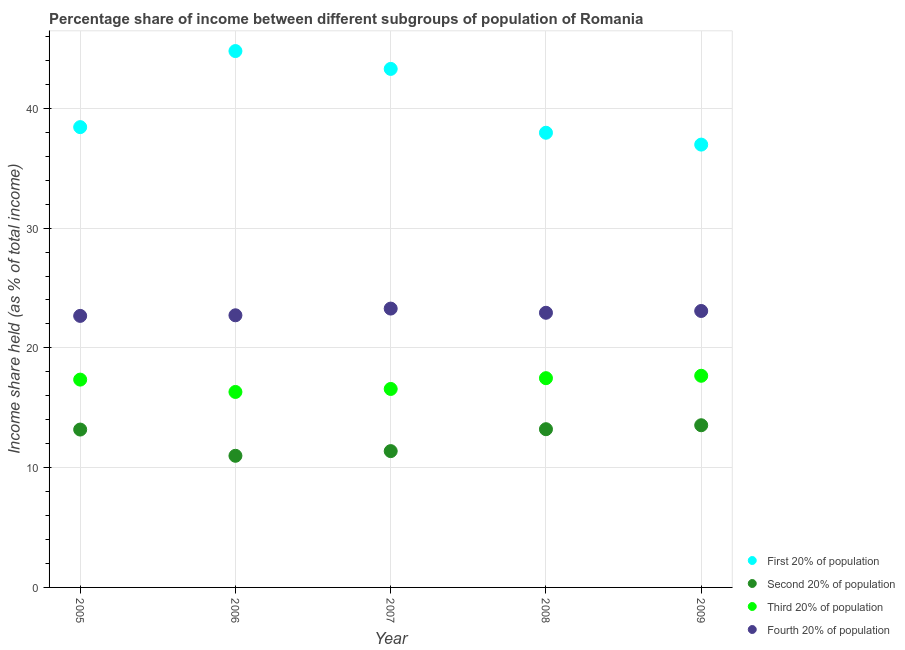What is the share of the income held by third 20% of the population in 2005?
Provide a short and direct response. 17.35. Across all years, what is the maximum share of the income held by fourth 20% of the population?
Your response must be concise. 23.28. Across all years, what is the minimum share of the income held by fourth 20% of the population?
Offer a terse response. 22.67. What is the total share of the income held by first 20% of the population in the graph?
Offer a very short reply. 201.43. What is the difference between the share of the income held by first 20% of the population in 2007 and that in 2008?
Offer a very short reply. 5.33. What is the difference between the share of the income held by first 20% of the population in 2007 and the share of the income held by fourth 20% of the population in 2005?
Your answer should be very brief. 20.62. What is the average share of the income held by third 20% of the population per year?
Provide a succinct answer. 17.08. In the year 2006, what is the difference between the share of the income held by fourth 20% of the population and share of the income held by first 20% of the population?
Make the answer very short. -22.06. In how many years, is the share of the income held by third 20% of the population greater than 20 %?
Give a very brief answer. 0. What is the ratio of the share of the income held by third 20% of the population in 2005 to that in 2006?
Provide a short and direct response. 1.06. Is the difference between the share of the income held by fourth 20% of the population in 2005 and 2009 greater than the difference between the share of the income held by first 20% of the population in 2005 and 2009?
Make the answer very short. No. What is the difference between the highest and the second highest share of the income held by third 20% of the population?
Keep it short and to the point. 0.2. What is the difference between the highest and the lowest share of the income held by first 20% of the population?
Keep it short and to the point. 7.81. Is it the case that in every year, the sum of the share of the income held by fourth 20% of the population and share of the income held by first 20% of the population is greater than the sum of share of the income held by third 20% of the population and share of the income held by second 20% of the population?
Your response must be concise. No. Is it the case that in every year, the sum of the share of the income held by first 20% of the population and share of the income held by second 20% of the population is greater than the share of the income held by third 20% of the population?
Give a very brief answer. Yes. Does the share of the income held by third 20% of the population monotonically increase over the years?
Provide a succinct answer. No. Is the share of the income held by fourth 20% of the population strictly greater than the share of the income held by second 20% of the population over the years?
Your response must be concise. Yes. How many dotlines are there?
Your answer should be compact. 4. What is the difference between two consecutive major ticks on the Y-axis?
Your answer should be compact. 10. Are the values on the major ticks of Y-axis written in scientific E-notation?
Your answer should be compact. No. Where does the legend appear in the graph?
Offer a terse response. Bottom right. How many legend labels are there?
Your response must be concise. 4. What is the title of the graph?
Your response must be concise. Percentage share of income between different subgroups of population of Romania. What is the label or title of the Y-axis?
Your response must be concise. Income share held (as % of total income). What is the Income share held (as % of total income) in First 20% of population in 2005?
Your answer should be very brief. 38.43. What is the Income share held (as % of total income) of Second 20% of population in 2005?
Offer a terse response. 13.18. What is the Income share held (as % of total income) in Third 20% of population in 2005?
Ensure brevity in your answer.  17.35. What is the Income share held (as % of total income) in Fourth 20% of population in 2005?
Keep it short and to the point. 22.67. What is the Income share held (as % of total income) of First 20% of population in 2006?
Give a very brief answer. 44.78. What is the Income share held (as % of total income) in Second 20% of population in 2006?
Your answer should be compact. 10.99. What is the Income share held (as % of total income) in Third 20% of population in 2006?
Ensure brevity in your answer.  16.32. What is the Income share held (as % of total income) in Fourth 20% of population in 2006?
Your response must be concise. 22.72. What is the Income share held (as % of total income) in First 20% of population in 2007?
Your answer should be compact. 43.29. What is the Income share held (as % of total income) in Second 20% of population in 2007?
Make the answer very short. 11.38. What is the Income share held (as % of total income) in Third 20% of population in 2007?
Your answer should be very brief. 16.57. What is the Income share held (as % of total income) in Fourth 20% of population in 2007?
Offer a terse response. 23.28. What is the Income share held (as % of total income) of First 20% of population in 2008?
Provide a short and direct response. 37.96. What is the Income share held (as % of total income) in Second 20% of population in 2008?
Your answer should be very brief. 13.21. What is the Income share held (as % of total income) of Third 20% of population in 2008?
Make the answer very short. 17.47. What is the Income share held (as % of total income) of Fourth 20% of population in 2008?
Provide a succinct answer. 22.93. What is the Income share held (as % of total income) of First 20% of population in 2009?
Keep it short and to the point. 36.97. What is the Income share held (as % of total income) in Second 20% of population in 2009?
Your answer should be compact. 13.54. What is the Income share held (as % of total income) in Third 20% of population in 2009?
Your answer should be compact. 17.67. What is the Income share held (as % of total income) of Fourth 20% of population in 2009?
Provide a short and direct response. 23.08. Across all years, what is the maximum Income share held (as % of total income) of First 20% of population?
Your response must be concise. 44.78. Across all years, what is the maximum Income share held (as % of total income) in Second 20% of population?
Provide a short and direct response. 13.54. Across all years, what is the maximum Income share held (as % of total income) of Third 20% of population?
Your response must be concise. 17.67. Across all years, what is the maximum Income share held (as % of total income) of Fourth 20% of population?
Keep it short and to the point. 23.28. Across all years, what is the minimum Income share held (as % of total income) of First 20% of population?
Make the answer very short. 36.97. Across all years, what is the minimum Income share held (as % of total income) in Second 20% of population?
Your answer should be compact. 10.99. Across all years, what is the minimum Income share held (as % of total income) in Third 20% of population?
Provide a succinct answer. 16.32. Across all years, what is the minimum Income share held (as % of total income) in Fourth 20% of population?
Offer a very short reply. 22.67. What is the total Income share held (as % of total income) in First 20% of population in the graph?
Ensure brevity in your answer.  201.43. What is the total Income share held (as % of total income) in Second 20% of population in the graph?
Your answer should be very brief. 62.3. What is the total Income share held (as % of total income) in Third 20% of population in the graph?
Your answer should be compact. 85.38. What is the total Income share held (as % of total income) in Fourth 20% of population in the graph?
Give a very brief answer. 114.68. What is the difference between the Income share held (as % of total income) of First 20% of population in 2005 and that in 2006?
Your answer should be compact. -6.35. What is the difference between the Income share held (as % of total income) of Second 20% of population in 2005 and that in 2006?
Give a very brief answer. 2.19. What is the difference between the Income share held (as % of total income) in Fourth 20% of population in 2005 and that in 2006?
Your answer should be compact. -0.05. What is the difference between the Income share held (as % of total income) of First 20% of population in 2005 and that in 2007?
Your answer should be compact. -4.86. What is the difference between the Income share held (as % of total income) in Second 20% of population in 2005 and that in 2007?
Provide a succinct answer. 1.8. What is the difference between the Income share held (as % of total income) in Third 20% of population in 2005 and that in 2007?
Your response must be concise. 0.78. What is the difference between the Income share held (as % of total income) in Fourth 20% of population in 2005 and that in 2007?
Keep it short and to the point. -0.61. What is the difference between the Income share held (as % of total income) in First 20% of population in 2005 and that in 2008?
Your answer should be compact. 0.47. What is the difference between the Income share held (as % of total income) in Second 20% of population in 2005 and that in 2008?
Ensure brevity in your answer.  -0.03. What is the difference between the Income share held (as % of total income) of Third 20% of population in 2005 and that in 2008?
Provide a succinct answer. -0.12. What is the difference between the Income share held (as % of total income) of Fourth 20% of population in 2005 and that in 2008?
Provide a succinct answer. -0.26. What is the difference between the Income share held (as % of total income) of First 20% of population in 2005 and that in 2009?
Offer a very short reply. 1.46. What is the difference between the Income share held (as % of total income) of Second 20% of population in 2005 and that in 2009?
Offer a terse response. -0.36. What is the difference between the Income share held (as % of total income) of Third 20% of population in 2005 and that in 2009?
Your answer should be compact. -0.32. What is the difference between the Income share held (as % of total income) of Fourth 20% of population in 2005 and that in 2009?
Keep it short and to the point. -0.41. What is the difference between the Income share held (as % of total income) of First 20% of population in 2006 and that in 2007?
Your answer should be compact. 1.49. What is the difference between the Income share held (as % of total income) in Second 20% of population in 2006 and that in 2007?
Provide a short and direct response. -0.39. What is the difference between the Income share held (as % of total income) of Fourth 20% of population in 2006 and that in 2007?
Your answer should be compact. -0.56. What is the difference between the Income share held (as % of total income) of First 20% of population in 2006 and that in 2008?
Ensure brevity in your answer.  6.82. What is the difference between the Income share held (as % of total income) in Second 20% of population in 2006 and that in 2008?
Your response must be concise. -2.22. What is the difference between the Income share held (as % of total income) of Third 20% of population in 2006 and that in 2008?
Provide a short and direct response. -1.15. What is the difference between the Income share held (as % of total income) in Fourth 20% of population in 2006 and that in 2008?
Offer a terse response. -0.21. What is the difference between the Income share held (as % of total income) in First 20% of population in 2006 and that in 2009?
Your response must be concise. 7.81. What is the difference between the Income share held (as % of total income) of Second 20% of population in 2006 and that in 2009?
Provide a succinct answer. -2.55. What is the difference between the Income share held (as % of total income) of Third 20% of population in 2006 and that in 2009?
Make the answer very short. -1.35. What is the difference between the Income share held (as % of total income) in Fourth 20% of population in 2006 and that in 2009?
Your answer should be very brief. -0.36. What is the difference between the Income share held (as % of total income) of First 20% of population in 2007 and that in 2008?
Ensure brevity in your answer.  5.33. What is the difference between the Income share held (as % of total income) of Second 20% of population in 2007 and that in 2008?
Ensure brevity in your answer.  -1.83. What is the difference between the Income share held (as % of total income) of Third 20% of population in 2007 and that in 2008?
Make the answer very short. -0.9. What is the difference between the Income share held (as % of total income) in First 20% of population in 2007 and that in 2009?
Keep it short and to the point. 6.32. What is the difference between the Income share held (as % of total income) in Second 20% of population in 2007 and that in 2009?
Offer a terse response. -2.16. What is the difference between the Income share held (as % of total income) in Fourth 20% of population in 2007 and that in 2009?
Your answer should be compact. 0.2. What is the difference between the Income share held (as % of total income) of First 20% of population in 2008 and that in 2009?
Your answer should be very brief. 0.99. What is the difference between the Income share held (as % of total income) of Second 20% of population in 2008 and that in 2009?
Provide a succinct answer. -0.33. What is the difference between the Income share held (as % of total income) in Third 20% of population in 2008 and that in 2009?
Ensure brevity in your answer.  -0.2. What is the difference between the Income share held (as % of total income) of Fourth 20% of population in 2008 and that in 2009?
Provide a succinct answer. -0.15. What is the difference between the Income share held (as % of total income) in First 20% of population in 2005 and the Income share held (as % of total income) in Second 20% of population in 2006?
Your response must be concise. 27.44. What is the difference between the Income share held (as % of total income) of First 20% of population in 2005 and the Income share held (as % of total income) of Third 20% of population in 2006?
Your response must be concise. 22.11. What is the difference between the Income share held (as % of total income) in First 20% of population in 2005 and the Income share held (as % of total income) in Fourth 20% of population in 2006?
Keep it short and to the point. 15.71. What is the difference between the Income share held (as % of total income) of Second 20% of population in 2005 and the Income share held (as % of total income) of Third 20% of population in 2006?
Your response must be concise. -3.14. What is the difference between the Income share held (as % of total income) in Second 20% of population in 2005 and the Income share held (as % of total income) in Fourth 20% of population in 2006?
Make the answer very short. -9.54. What is the difference between the Income share held (as % of total income) of Third 20% of population in 2005 and the Income share held (as % of total income) of Fourth 20% of population in 2006?
Your response must be concise. -5.37. What is the difference between the Income share held (as % of total income) in First 20% of population in 2005 and the Income share held (as % of total income) in Second 20% of population in 2007?
Make the answer very short. 27.05. What is the difference between the Income share held (as % of total income) in First 20% of population in 2005 and the Income share held (as % of total income) in Third 20% of population in 2007?
Your response must be concise. 21.86. What is the difference between the Income share held (as % of total income) of First 20% of population in 2005 and the Income share held (as % of total income) of Fourth 20% of population in 2007?
Make the answer very short. 15.15. What is the difference between the Income share held (as % of total income) of Second 20% of population in 2005 and the Income share held (as % of total income) of Third 20% of population in 2007?
Offer a terse response. -3.39. What is the difference between the Income share held (as % of total income) in Third 20% of population in 2005 and the Income share held (as % of total income) in Fourth 20% of population in 2007?
Give a very brief answer. -5.93. What is the difference between the Income share held (as % of total income) of First 20% of population in 2005 and the Income share held (as % of total income) of Second 20% of population in 2008?
Keep it short and to the point. 25.22. What is the difference between the Income share held (as % of total income) of First 20% of population in 2005 and the Income share held (as % of total income) of Third 20% of population in 2008?
Provide a succinct answer. 20.96. What is the difference between the Income share held (as % of total income) in First 20% of population in 2005 and the Income share held (as % of total income) in Fourth 20% of population in 2008?
Provide a short and direct response. 15.5. What is the difference between the Income share held (as % of total income) of Second 20% of population in 2005 and the Income share held (as % of total income) of Third 20% of population in 2008?
Give a very brief answer. -4.29. What is the difference between the Income share held (as % of total income) of Second 20% of population in 2005 and the Income share held (as % of total income) of Fourth 20% of population in 2008?
Your answer should be very brief. -9.75. What is the difference between the Income share held (as % of total income) in Third 20% of population in 2005 and the Income share held (as % of total income) in Fourth 20% of population in 2008?
Keep it short and to the point. -5.58. What is the difference between the Income share held (as % of total income) of First 20% of population in 2005 and the Income share held (as % of total income) of Second 20% of population in 2009?
Make the answer very short. 24.89. What is the difference between the Income share held (as % of total income) in First 20% of population in 2005 and the Income share held (as % of total income) in Third 20% of population in 2009?
Keep it short and to the point. 20.76. What is the difference between the Income share held (as % of total income) in First 20% of population in 2005 and the Income share held (as % of total income) in Fourth 20% of population in 2009?
Provide a succinct answer. 15.35. What is the difference between the Income share held (as % of total income) of Second 20% of population in 2005 and the Income share held (as % of total income) of Third 20% of population in 2009?
Your answer should be very brief. -4.49. What is the difference between the Income share held (as % of total income) of Second 20% of population in 2005 and the Income share held (as % of total income) of Fourth 20% of population in 2009?
Your answer should be compact. -9.9. What is the difference between the Income share held (as % of total income) of Third 20% of population in 2005 and the Income share held (as % of total income) of Fourth 20% of population in 2009?
Provide a short and direct response. -5.73. What is the difference between the Income share held (as % of total income) of First 20% of population in 2006 and the Income share held (as % of total income) of Second 20% of population in 2007?
Your response must be concise. 33.4. What is the difference between the Income share held (as % of total income) in First 20% of population in 2006 and the Income share held (as % of total income) in Third 20% of population in 2007?
Your answer should be compact. 28.21. What is the difference between the Income share held (as % of total income) of Second 20% of population in 2006 and the Income share held (as % of total income) of Third 20% of population in 2007?
Your response must be concise. -5.58. What is the difference between the Income share held (as % of total income) of Second 20% of population in 2006 and the Income share held (as % of total income) of Fourth 20% of population in 2007?
Offer a terse response. -12.29. What is the difference between the Income share held (as % of total income) of Third 20% of population in 2006 and the Income share held (as % of total income) of Fourth 20% of population in 2007?
Offer a very short reply. -6.96. What is the difference between the Income share held (as % of total income) in First 20% of population in 2006 and the Income share held (as % of total income) in Second 20% of population in 2008?
Offer a terse response. 31.57. What is the difference between the Income share held (as % of total income) of First 20% of population in 2006 and the Income share held (as % of total income) of Third 20% of population in 2008?
Offer a terse response. 27.31. What is the difference between the Income share held (as % of total income) of First 20% of population in 2006 and the Income share held (as % of total income) of Fourth 20% of population in 2008?
Offer a very short reply. 21.85. What is the difference between the Income share held (as % of total income) of Second 20% of population in 2006 and the Income share held (as % of total income) of Third 20% of population in 2008?
Your response must be concise. -6.48. What is the difference between the Income share held (as % of total income) in Second 20% of population in 2006 and the Income share held (as % of total income) in Fourth 20% of population in 2008?
Your answer should be very brief. -11.94. What is the difference between the Income share held (as % of total income) of Third 20% of population in 2006 and the Income share held (as % of total income) of Fourth 20% of population in 2008?
Your response must be concise. -6.61. What is the difference between the Income share held (as % of total income) in First 20% of population in 2006 and the Income share held (as % of total income) in Second 20% of population in 2009?
Your answer should be compact. 31.24. What is the difference between the Income share held (as % of total income) of First 20% of population in 2006 and the Income share held (as % of total income) of Third 20% of population in 2009?
Offer a terse response. 27.11. What is the difference between the Income share held (as % of total income) in First 20% of population in 2006 and the Income share held (as % of total income) in Fourth 20% of population in 2009?
Make the answer very short. 21.7. What is the difference between the Income share held (as % of total income) of Second 20% of population in 2006 and the Income share held (as % of total income) of Third 20% of population in 2009?
Keep it short and to the point. -6.68. What is the difference between the Income share held (as % of total income) of Second 20% of population in 2006 and the Income share held (as % of total income) of Fourth 20% of population in 2009?
Keep it short and to the point. -12.09. What is the difference between the Income share held (as % of total income) of Third 20% of population in 2006 and the Income share held (as % of total income) of Fourth 20% of population in 2009?
Ensure brevity in your answer.  -6.76. What is the difference between the Income share held (as % of total income) in First 20% of population in 2007 and the Income share held (as % of total income) in Second 20% of population in 2008?
Your response must be concise. 30.08. What is the difference between the Income share held (as % of total income) in First 20% of population in 2007 and the Income share held (as % of total income) in Third 20% of population in 2008?
Provide a succinct answer. 25.82. What is the difference between the Income share held (as % of total income) in First 20% of population in 2007 and the Income share held (as % of total income) in Fourth 20% of population in 2008?
Provide a short and direct response. 20.36. What is the difference between the Income share held (as % of total income) of Second 20% of population in 2007 and the Income share held (as % of total income) of Third 20% of population in 2008?
Provide a succinct answer. -6.09. What is the difference between the Income share held (as % of total income) of Second 20% of population in 2007 and the Income share held (as % of total income) of Fourth 20% of population in 2008?
Provide a short and direct response. -11.55. What is the difference between the Income share held (as % of total income) in Third 20% of population in 2007 and the Income share held (as % of total income) in Fourth 20% of population in 2008?
Your response must be concise. -6.36. What is the difference between the Income share held (as % of total income) of First 20% of population in 2007 and the Income share held (as % of total income) of Second 20% of population in 2009?
Your answer should be very brief. 29.75. What is the difference between the Income share held (as % of total income) of First 20% of population in 2007 and the Income share held (as % of total income) of Third 20% of population in 2009?
Give a very brief answer. 25.62. What is the difference between the Income share held (as % of total income) in First 20% of population in 2007 and the Income share held (as % of total income) in Fourth 20% of population in 2009?
Ensure brevity in your answer.  20.21. What is the difference between the Income share held (as % of total income) of Second 20% of population in 2007 and the Income share held (as % of total income) of Third 20% of population in 2009?
Offer a terse response. -6.29. What is the difference between the Income share held (as % of total income) of Second 20% of population in 2007 and the Income share held (as % of total income) of Fourth 20% of population in 2009?
Provide a short and direct response. -11.7. What is the difference between the Income share held (as % of total income) in Third 20% of population in 2007 and the Income share held (as % of total income) in Fourth 20% of population in 2009?
Provide a short and direct response. -6.51. What is the difference between the Income share held (as % of total income) in First 20% of population in 2008 and the Income share held (as % of total income) in Second 20% of population in 2009?
Give a very brief answer. 24.42. What is the difference between the Income share held (as % of total income) in First 20% of population in 2008 and the Income share held (as % of total income) in Third 20% of population in 2009?
Provide a succinct answer. 20.29. What is the difference between the Income share held (as % of total income) of First 20% of population in 2008 and the Income share held (as % of total income) of Fourth 20% of population in 2009?
Keep it short and to the point. 14.88. What is the difference between the Income share held (as % of total income) of Second 20% of population in 2008 and the Income share held (as % of total income) of Third 20% of population in 2009?
Your answer should be compact. -4.46. What is the difference between the Income share held (as % of total income) of Second 20% of population in 2008 and the Income share held (as % of total income) of Fourth 20% of population in 2009?
Give a very brief answer. -9.87. What is the difference between the Income share held (as % of total income) in Third 20% of population in 2008 and the Income share held (as % of total income) in Fourth 20% of population in 2009?
Provide a short and direct response. -5.61. What is the average Income share held (as % of total income) in First 20% of population per year?
Provide a short and direct response. 40.29. What is the average Income share held (as % of total income) in Second 20% of population per year?
Offer a terse response. 12.46. What is the average Income share held (as % of total income) in Third 20% of population per year?
Ensure brevity in your answer.  17.08. What is the average Income share held (as % of total income) in Fourth 20% of population per year?
Offer a very short reply. 22.94. In the year 2005, what is the difference between the Income share held (as % of total income) of First 20% of population and Income share held (as % of total income) of Second 20% of population?
Give a very brief answer. 25.25. In the year 2005, what is the difference between the Income share held (as % of total income) of First 20% of population and Income share held (as % of total income) of Third 20% of population?
Offer a terse response. 21.08. In the year 2005, what is the difference between the Income share held (as % of total income) in First 20% of population and Income share held (as % of total income) in Fourth 20% of population?
Provide a succinct answer. 15.76. In the year 2005, what is the difference between the Income share held (as % of total income) of Second 20% of population and Income share held (as % of total income) of Third 20% of population?
Provide a succinct answer. -4.17. In the year 2005, what is the difference between the Income share held (as % of total income) in Second 20% of population and Income share held (as % of total income) in Fourth 20% of population?
Make the answer very short. -9.49. In the year 2005, what is the difference between the Income share held (as % of total income) in Third 20% of population and Income share held (as % of total income) in Fourth 20% of population?
Your answer should be very brief. -5.32. In the year 2006, what is the difference between the Income share held (as % of total income) of First 20% of population and Income share held (as % of total income) of Second 20% of population?
Your answer should be compact. 33.79. In the year 2006, what is the difference between the Income share held (as % of total income) in First 20% of population and Income share held (as % of total income) in Third 20% of population?
Offer a very short reply. 28.46. In the year 2006, what is the difference between the Income share held (as % of total income) of First 20% of population and Income share held (as % of total income) of Fourth 20% of population?
Make the answer very short. 22.06. In the year 2006, what is the difference between the Income share held (as % of total income) of Second 20% of population and Income share held (as % of total income) of Third 20% of population?
Your answer should be compact. -5.33. In the year 2006, what is the difference between the Income share held (as % of total income) in Second 20% of population and Income share held (as % of total income) in Fourth 20% of population?
Provide a succinct answer. -11.73. In the year 2006, what is the difference between the Income share held (as % of total income) of Third 20% of population and Income share held (as % of total income) of Fourth 20% of population?
Offer a terse response. -6.4. In the year 2007, what is the difference between the Income share held (as % of total income) in First 20% of population and Income share held (as % of total income) in Second 20% of population?
Make the answer very short. 31.91. In the year 2007, what is the difference between the Income share held (as % of total income) of First 20% of population and Income share held (as % of total income) of Third 20% of population?
Offer a terse response. 26.72. In the year 2007, what is the difference between the Income share held (as % of total income) of First 20% of population and Income share held (as % of total income) of Fourth 20% of population?
Your answer should be compact. 20.01. In the year 2007, what is the difference between the Income share held (as % of total income) of Second 20% of population and Income share held (as % of total income) of Third 20% of population?
Keep it short and to the point. -5.19. In the year 2007, what is the difference between the Income share held (as % of total income) in Third 20% of population and Income share held (as % of total income) in Fourth 20% of population?
Your response must be concise. -6.71. In the year 2008, what is the difference between the Income share held (as % of total income) in First 20% of population and Income share held (as % of total income) in Second 20% of population?
Give a very brief answer. 24.75. In the year 2008, what is the difference between the Income share held (as % of total income) in First 20% of population and Income share held (as % of total income) in Third 20% of population?
Give a very brief answer. 20.49. In the year 2008, what is the difference between the Income share held (as % of total income) of First 20% of population and Income share held (as % of total income) of Fourth 20% of population?
Your response must be concise. 15.03. In the year 2008, what is the difference between the Income share held (as % of total income) of Second 20% of population and Income share held (as % of total income) of Third 20% of population?
Your answer should be very brief. -4.26. In the year 2008, what is the difference between the Income share held (as % of total income) in Second 20% of population and Income share held (as % of total income) in Fourth 20% of population?
Make the answer very short. -9.72. In the year 2008, what is the difference between the Income share held (as % of total income) of Third 20% of population and Income share held (as % of total income) of Fourth 20% of population?
Make the answer very short. -5.46. In the year 2009, what is the difference between the Income share held (as % of total income) of First 20% of population and Income share held (as % of total income) of Second 20% of population?
Your answer should be very brief. 23.43. In the year 2009, what is the difference between the Income share held (as % of total income) of First 20% of population and Income share held (as % of total income) of Third 20% of population?
Your answer should be compact. 19.3. In the year 2009, what is the difference between the Income share held (as % of total income) in First 20% of population and Income share held (as % of total income) in Fourth 20% of population?
Give a very brief answer. 13.89. In the year 2009, what is the difference between the Income share held (as % of total income) of Second 20% of population and Income share held (as % of total income) of Third 20% of population?
Your answer should be very brief. -4.13. In the year 2009, what is the difference between the Income share held (as % of total income) of Second 20% of population and Income share held (as % of total income) of Fourth 20% of population?
Make the answer very short. -9.54. In the year 2009, what is the difference between the Income share held (as % of total income) of Third 20% of population and Income share held (as % of total income) of Fourth 20% of population?
Make the answer very short. -5.41. What is the ratio of the Income share held (as % of total income) in First 20% of population in 2005 to that in 2006?
Your response must be concise. 0.86. What is the ratio of the Income share held (as % of total income) in Second 20% of population in 2005 to that in 2006?
Make the answer very short. 1.2. What is the ratio of the Income share held (as % of total income) of Third 20% of population in 2005 to that in 2006?
Your answer should be compact. 1.06. What is the ratio of the Income share held (as % of total income) in First 20% of population in 2005 to that in 2007?
Your answer should be compact. 0.89. What is the ratio of the Income share held (as % of total income) of Second 20% of population in 2005 to that in 2007?
Your answer should be very brief. 1.16. What is the ratio of the Income share held (as % of total income) in Third 20% of population in 2005 to that in 2007?
Offer a very short reply. 1.05. What is the ratio of the Income share held (as % of total income) in Fourth 20% of population in 2005 to that in 2007?
Keep it short and to the point. 0.97. What is the ratio of the Income share held (as % of total income) in First 20% of population in 2005 to that in 2008?
Make the answer very short. 1.01. What is the ratio of the Income share held (as % of total income) of Second 20% of population in 2005 to that in 2008?
Keep it short and to the point. 1. What is the ratio of the Income share held (as % of total income) of Third 20% of population in 2005 to that in 2008?
Provide a succinct answer. 0.99. What is the ratio of the Income share held (as % of total income) in Fourth 20% of population in 2005 to that in 2008?
Ensure brevity in your answer.  0.99. What is the ratio of the Income share held (as % of total income) of First 20% of population in 2005 to that in 2009?
Your answer should be compact. 1.04. What is the ratio of the Income share held (as % of total income) in Second 20% of population in 2005 to that in 2009?
Keep it short and to the point. 0.97. What is the ratio of the Income share held (as % of total income) in Third 20% of population in 2005 to that in 2009?
Give a very brief answer. 0.98. What is the ratio of the Income share held (as % of total income) of Fourth 20% of population in 2005 to that in 2009?
Offer a very short reply. 0.98. What is the ratio of the Income share held (as % of total income) of First 20% of population in 2006 to that in 2007?
Offer a terse response. 1.03. What is the ratio of the Income share held (as % of total income) of Second 20% of population in 2006 to that in 2007?
Your answer should be compact. 0.97. What is the ratio of the Income share held (as % of total income) in Third 20% of population in 2006 to that in 2007?
Your answer should be very brief. 0.98. What is the ratio of the Income share held (as % of total income) in Fourth 20% of population in 2006 to that in 2007?
Your answer should be compact. 0.98. What is the ratio of the Income share held (as % of total income) in First 20% of population in 2006 to that in 2008?
Offer a very short reply. 1.18. What is the ratio of the Income share held (as % of total income) of Second 20% of population in 2006 to that in 2008?
Give a very brief answer. 0.83. What is the ratio of the Income share held (as % of total income) in Third 20% of population in 2006 to that in 2008?
Your answer should be very brief. 0.93. What is the ratio of the Income share held (as % of total income) of Fourth 20% of population in 2006 to that in 2008?
Your response must be concise. 0.99. What is the ratio of the Income share held (as % of total income) in First 20% of population in 2006 to that in 2009?
Your answer should be very brief. 1.21. What is the ratio of the Income share held (as % of total income) of Second 20% of population in 2006 to that in 2009?
Ensure brevity in your answer.  0.81. What is the ratio of the Income share held (as % of total income) of Third 20% of population in 2006 to that in 2009?
Offer a very short reply. 0.92. What is the ratio of the Income share held (as % of total income) of Fourth 20% of population in 2006 to that in 2009?
Your answer should be very brief. 0.98. What is the ratio of the Income share held (as % of total income) in First 20% of population in 2007 to that in 2008?
Give a very brief answer. 1.14. What is the ratio of the Income share held (as % of total income) of Second 20% of population in 2007 to that in 2008?
Give a very brief answer. 0.86. What is the ratio of the Income share held (as % of total income) in Third 20% of population in 2007 to that in 2008?
Keep it short and to the point. 0.95. What is the ratio of the Income share held (as % of total income) in Fourth 20% of population in 2007 to that in 2008?
Your answer should be very brief. 1.02. What is the ratio of the Income share held (as % of total income) of First 20% of population in 2007 to that in 2009?
Keep it short and to the point. 1.17. What is the ratio of the Income share held (as % of total income) in Second 20% of population in 2007 to that in 2009?
Provide a short and direct response. 0.84. What is the ratio of the Income share held (as % of total income) in Third 20% of population in 2007 to that in 2009?
Provide a short and direct response. 0.94. What is the ratio of the Income share held (as % of total income) in Fourth 20% of population in 2007 to that in 2009?
Offer a terse response. 1.01. What is the ratio of the Income share held (as % of total income) in First 20% of population in 2008 to that in 2009?
Offer a terse response. 1.03. What is the ratio of the Income share held (as % of total income) of Second 20% of population in 2008 to that in 2009?
Ensure brevity in your answer.  0.98. What is the ratio of the Income share held (as % of total income) in Third 20% of population in 2008 to that in 2009?
Give a very brief answer. 0.99. What is the ratio of the Income share held (as % of total income) in Fourth 20% of population in 2008 to that in 2009?
Ensure brevity in your answer.  0.99. What is the difference between the highest and the second highest Income share held (as % of total income) of First 20% of population?
Your response must be concise. 1.49. What is the difference between the highest and the second highest Income share held (as % of total income) of Second 20% of population?
Keep it short and to the point. 0.33. What is the difference between the highest and the second highest Income share held (as % of total income) of Third 20% of population?
Offer a terse response. 0.2. What is the difference between the highest and the lowest Income share held (as % of total income) in First 20% of population?
Offer a terse response. 7.81. What is the difference between the highest and the lowest Income share held (as % of total income) of Second 20% of population?
Your answer should be very brief. 2.55. What is the difference between the highest and the lowest Income share held (as % of total income) in Third 20% of population?
Provide a succinct answer. 1.35. What is the difference between the highest and the lowest Income share held (as % of total income) in Fourth 20% of population?
Offer a very short reply. 0.61. 